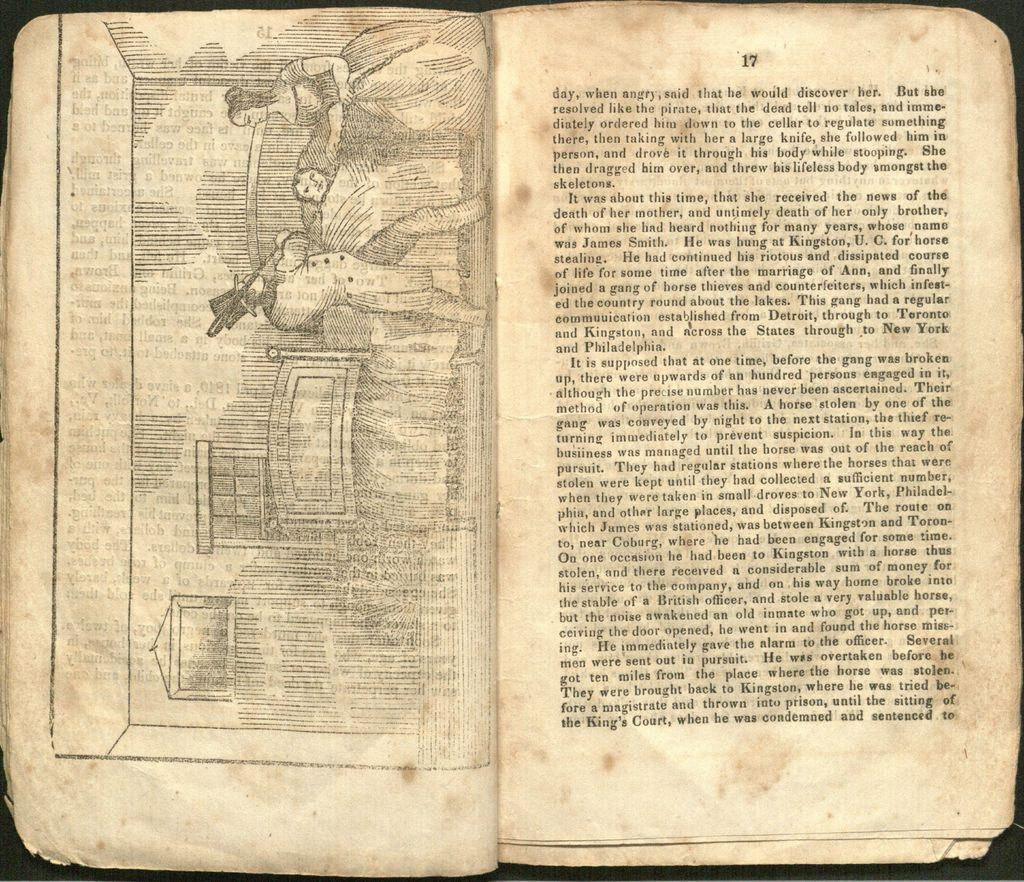<image>
Render a clear and concise summary of the photo. a book with the pages open with the number 17 on the top of it 